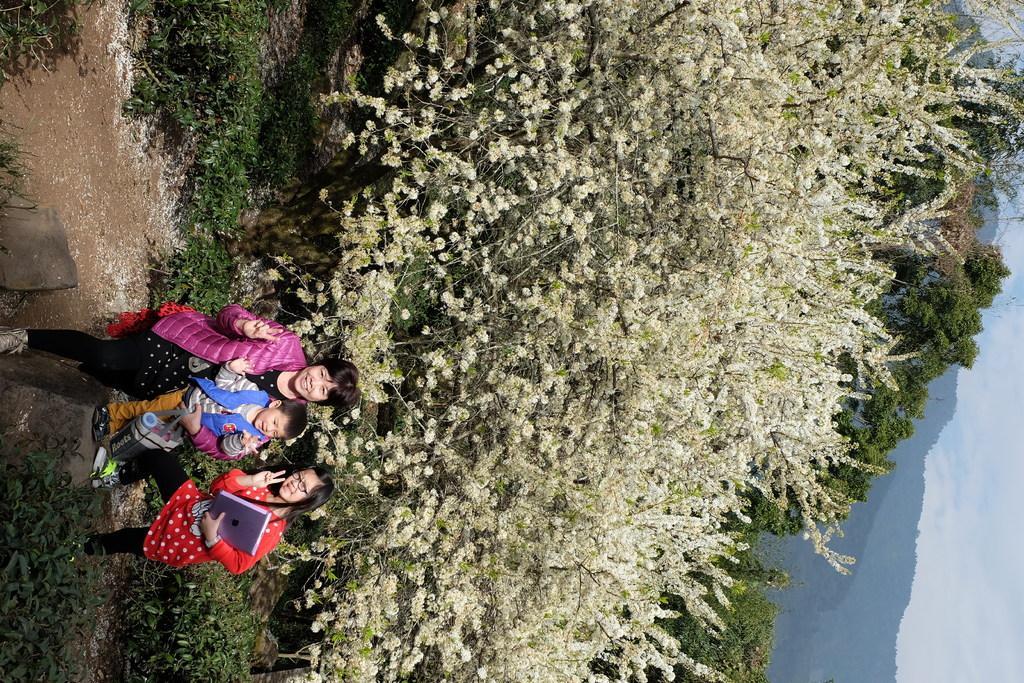Can you describe this image briefly? This picture is clicked outside the city. On the left we can see a woman holding a baby and standing on the ground and there is a girl holding a book and standing on the ground. In the background we can see the sky, hills and trees and the plants. 